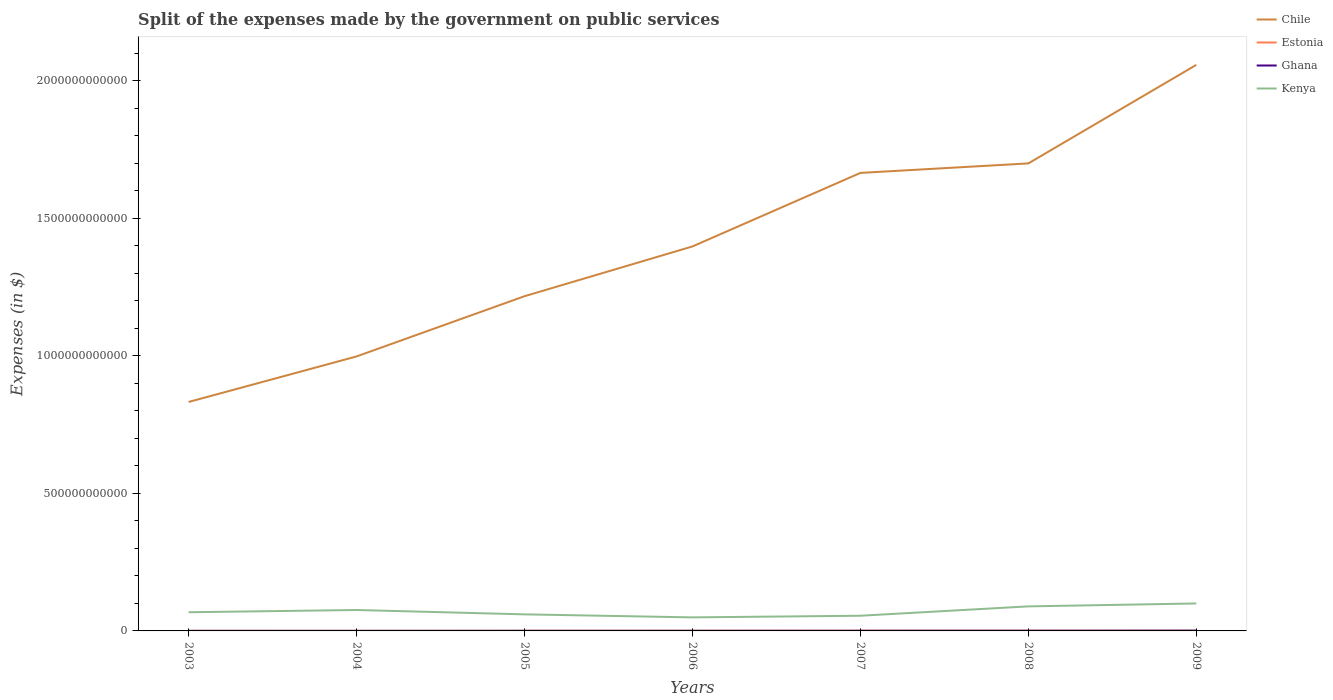Does the line corresponding to Ghana intersect with the line corresponding to Kenya?
Offer a terse response. No. Across all years, what is the maximum expenses made by the government on public services in Estonia?
Your answer should be compact. 4.04e+08. In which year was the expenses made by the government on public services in Ghana maximum?
Make the answer very short. 2003. What is the total expenses made by the government on public services in Kenya in the graph?
Make the answer very short. -5.98e+09. What is the difference between the highest and the second highest expenses made by the government on public services in Kenya?
Keep it short and to the point. 5.06e+1. How many lines are there?
Offer a very short reply. 4. What is the difference between two consecutive major ticks on the Y-axis?
Ensure brevity in your answer.  5.00e+11. Are the values on the major ticks of Y-axis written in scientific E-notation?
Make the answer very short. No. Does the graph contain any zero values?
Provide a short and direct response. No. How are the legend labels stacked?
Your answer should be very brief. Vertical. What is the title of the graph?
Keep it short and to the point. Split of the expenses made by the government on public services. Does "Lower middle income" appear as one of the legend labels in the graph?
Ensure brevity in your answer.  No. What is the label or title of the X-axis?
Your answer should be compact. Years. What is the label or title of the Y-axis?
Your response must be concise. Expenses (in $). What is the Expenses (in $) of Chile in 2003?
Keep it short and to the point. 8.32e+11. What is the Expenses (in $) of Estonia in 2003?
Ensure brevity in your answer.  4.29e+08. What is the Expenses (in $) of Ghana in 2003?
Provide a succinct answer. 2.06e+08. What is the Expenses (in $) in Kenya in 2003?
Keep it short and to the point. 6.79e+1. What is the Expenses (in $) of Chile in 2004?
Make the answer very short. 9.98e+11. What is the Expenses (in $) of Estonia in 2004?
Keep it short and to the point. 4.04e+08. What is the Expenses (in $) of Ghana in 2004?
Offer a very short reply. 2.46e+08. What is the Expenses (in $) in Kenya in 2004?
Your answer should be compact. 7.61e+1. What is the Expenses (in $) of Chile in 2005?
Ensure brevity in your answer.  1.22e+12. What is the Expenses (in $) of Estonia in 2005?
Your response must be concise. 4.46e+08. What is the Expenses (in $) in Ghana in 2005?
Ensure brevity in your answer.  4.02e+08. What is the Expenses (in $) in Kenya in 2005?
Provide a succinct answer. 6.02e+1. What is the Expenses (in $) of Chile in 2006?
Offer a very short reply. 1.40e+12. What is the Expenses (in $) of Estonia in 2006?
Offer a very short reply. 5.12e+08. What is the Expenses (in $) in Ghana in 2006?
Your answer should be compact. 4.57e+08. What is the Expenses (in $) of Kenya in 2006?
Offer a terse response. 4.92e+1. What is the Expenses (in $) in Chile in 2007?
Provide a succinct answer. 1.67e+12. What is the Expenses (in $) of Estonia in 2007?
Make the answer very short. 5.78e+08. What is the Expenses (in $) in Ghana in 2007?
Make the answer very short. 6.16e+08. What is the Expenses (in $) in Kenya in 2007?
Provide a succinct answer. 5.52e+1. What is the Expenses (in $) of Chile in 2008?
Your answer should be very brief. 1.70e+12. What is the Expenses (in $) in Estonia in 2008?
Keep it short and to the point. 6.60e+08. What is the Expenses (in $) of Ghana in 2008?
Offer a very short reply. 7.44e+08. What is the Expenses (in $) in Kenya in 2008?
Provide a short and direct response. 8.93e+1. What is the Expenses (in $) in Chile in 2009?
Provide a short and direct response. 2.06e+12. What is the Expenses (in $) in Estonia in 2009?
Your answer should be very brief. 6.36e+08. What is the Expenses (in $) in Ghana in 2009?
Your response must be concise. 1.09e+09. What is the Expenses (in $) in Kenya in 2009?
Offer a very short reply. 9.98e+1. Across all years, what is the maximum Expenses (in $) of Chile?
Keep it short and to the point. 2.06e+12. Across all years, what is the maximum Expenses (in $) of Estonia?
Your answer should be very brief. 6.60e+08. Across all years, what is the maximum Expenses (in $) of Ghana?
Ensure brevity in your answer.  1.09e+09. Across all years, what is the maximum Expenses (in $) in Kenya?
Your answer should be very brief. 9.98e+1. Across all years, what is the minimum Expenses (in $) in Chile?
Provide a succinct answer. 8.32e+11. Across all years, what is the minimum Expenses (in $) of Estonia?
Ensure brevity in your answer.  4.04e+08. Across all years, what is the minimum Expenses (in $) in Ghana?
Your response must be concise. 2.06e+08. Across all years, what is the minimum Expenses (in $) of Kenya?
Ensure brevity in your answer.  4.92e+1. What is the total Expenses (in $) of Chile in the graph?
Your answer should be very brief. 9.87e+12. What is the total Expenses (in $) in Estonia in the graph?
Your answer should be compact. 3.67e+09. What is the total Expenses (in $) of Ghana in the graph?
Offer a terse response. 3.76e+09. What is the total Expenses (in $) of Kenya in the graph?
Provide a short and direct response. 4.98e+11. What is the difference between the Expenses (in $) in Chile in 2003 and that in 2004?
Provide a succinct answer. -1.66e+11. What is the difference between the Expenses (in $) of Estonia in 2003 and that in 2004?
Offer a terse response. 2.44e+07. What is the difference between the Expenses (in $) of Ghana in 2003 and that in 2004?
Your answer should be very brief. -4.02e+07. What is the difference between the Expenses (in $) of Kenya in 2003 and that in 2004?
Make the answer very short. -8.12e+09. What is the difference between the Expenses (in $) of Chile in 2003 and that in 2005?
Your answer should be very brief. -3.85e+11. What is the difference between the Expenses (in $) of Estonia in 2003 and that in 2005?
Your answer should be compact. -1.75e+07. What is the difference between the Expenses (in $) of Ghana in 2003 and that in 2005?
Offer a very short reply. -1.96e+08. What is the difference between the Expenses (in $) in Kenya in 2003 and that in 2005?
Keep it short and to the point. 7.74e+09. What is the difference between the Expenses (in $) in Chile in 2003 and that in 2006?
Ensure brevity in your answer.  -5.66e+11. What is the difference between the Expenses (in $) of Estonia in 2003 and that in 2006?
Provide a short and direct response. -8.26e+07. What is the difference between the Expenses (in $) in Ghana in 2003 and that in 2006?
Offer a terse response. -2.51e+08. What is the difference between the Expenses (in $) in Kenya in 2003 and that in 2006?
Provide a succinct answer. 1.87e+1. What is the difference between the Expenses (in $) of Chile in 2003 and that in 2007?
Keep it short and to the point. -8.33e+11. What is the difference between the Expenses (in $) in Estonia in 2003 and that in 2007?
Your answer should be compact. -1.49e+08. What is the difference between the Expenses (in $) in Ghana in 2003 and that in 2007?
Your response must be concise. -4.10e+08. What is the difference between the Expenses (in $) in Kenya in 2003 and that in 2007?
Provide a succinct answer. 1.27e+1. What is the difference between the Expenses (in $) in Chile in 2003 and that in 2008?
Ensure brevity in your answer.  -8.67e+11. What is the difference between the Expenses (in $) of Estonia in 2003 and that in 2008?
Your response must be concise. -2.31e+08. What is the difference between the Expenses (in $) in Ghana in 2003 and that in 2008?
Provide a succinct answer. -5.38e+08. What is the difference between the Expenses (in $) of Kenya in 2003 and that in 2008?
Ensure brevity in your answer.  -2.13e+1. What is the difference between the Expenses (in $) of Chile in 2003 and that in 2009?
Keep it short and to the point. -1.23e+12. What is the difference between the Expenses (in $) of Estonia in 2003 and that in 2009?
Provide a short and direct response. -2.08e+08. What is the difference between the Expenses (in $) in Ghana in 2003 and that in 2009?
Provide a short and direct response. -8.81e+08. What is the difference between the Expenses (in $) of Kenya in 2003 and that in 2009?
Your answer should be very brief. -3.19e+1. What is the difference between the Expenses (in $) in Chile in 2004 and that in 2005?
Provide a short and direct response. -2.19e+11. What is the difference between the Expenses (in $) in Estonia in 2004 and that in 2005?
Give a very brief answer. -4.19e+07. What is the difference between the Expenses (in $) of Ghana in 2004 and that in 2005?
Your response must be concise. -1.56e+08. What is the difference between the Expenses (in $) in Kenya in 2004 and that in 2005?
Provide a succinct answer. 1.59e+1. What is the difference between the Expenses (in $) in Chile in 2004 and that in 2006?
Your answer should be compact. -4.00e+11. What is the difference between the Expenses (in $) of Estonia in 2004 and that in 2006?
Provide a short and direct response. -1.07e+08. What is the difference between the Expenses (in $) of Ghana in 2004 and that in 2006?
Keep it short and to the point. -2.11e+08. What is the difference between the Expenses (in $) in Kenya in 2004 and that in 2006?
Make the answer very short. 2.68e+1. What is the difference between the Expenses (in $) of Chile in 2004 and that in 2007?
Make the answer very short. -6.67e+11. What is the difference between the Expenses (in $) of Estonia in 2004 and that in 2007?
Give a very brief answer. -1.74e+08. What is the difference between the Expenses (in $) of Ghana in 2004 and that in 2007?
Provide a short and direct response. -3.70e+08. What is the difference between the Expenses (in $) in Kenya in 2004 and that in 2007?
Your response must be concise. 2.08e+1. What is the difference between the Expenses (in $) in Chile in 2004 and that in 2008?
Offer a terse response. -7.02e+11. What is the difference between the Expenses (in $) of Estonia in 2004 and that in 2008?
Keep it short and to the point. -2.56e+08. What is the difference between the Expenses (in $) in Ghana in 2004 and that in 2008?
Give a very brief answer. -4.98e+08. What is the difference between the Expenses (in $) in Kenya in 2004 and that in 2008?
Make the answer very short. -1.32e+1. What is the difference between the Expenses (in $) in Chile in 2004 and that in 2009?
Offer a terse response. -1.06e+12. What is the difference between the Expenses (in $) of Estonia in 2004 and that in 2009?
Ensure brevity in your answer.  -2.32e+08. What is the difference between the Expenses (in $) of Ghana in 2004 and that in 2009?
Your answer should be very brief. -8.41e+08. What is the difference between the Expenses (in $) in Kenya in 2004 and that in 2009?
Your answer should be very brief. -2.38e+1. What is the difference between the Expenses (in $) of Chile in 2005 and that in 2006?
Your answer should be compact. -1.81e+11. What is the difference between the Expenses (in $) of Estonia in 2005 and that in 2006?
Give a very brief answer. -6.51e+07. What is the difference between the Expenses (in $) of Ghana in 2005 and that in 2006?
Your answer should be very brief. -5.49e+07. What is the difference between the Expenses (in $) of Kenya in 2005 and that in 2006?
Ensure brevity in your answer.  1.10e+1. What is the difference between the Expenses (in $) in Chile in 2005 and that in 2007?
Provide a short and direct response. -4.48e+11. What is the difference between the Expenses (in $) of Estonia in 2005 and that in 2007?
Ensure brevity in your answer.  -1.32e+08. What is the difference between the Expenses (in $) of Ghana in 2005 and that in 2007?
Ensure brevity in your answer.  -2.14e+08. What is the difference between the Expenses (in $) of Kenya in 2005 and that in 2007?
Provide a short and direct response. 4.99e+09. What is the difference between the Expenses (in $) of Chile in 2005 and that in 2008?
Provide a short and direct response. -4.83e+11. What is the difference between the Expenses (in $) in Estonia in 2005 and that in 2008?
Offer a very short reply. -2.14e+08. What is the difference between the Expenses (in $) in Ghana in 2005 and that in 2008?
Provide a succinct answer. -3.42e+08. What is the difference between the Expenses (in $) of Kenya in 2005 and that in 2008?
Keep it short and to the point. -2.91e+1. What is the difference between the Expenses (in $) in Chile in 2005 and that in 2009?
Your response must be concise. -8.41e+11. What is the difference between the Expenses (in $) of Estonia in 2005 and that in 2009?
Provide a succinct answer. -1.90e+08. What is the difference between the Expenses (in $) in Ghana in 2005 and that in 2009?
Offer a terse response. -6.85e+08. What is the difference between the Expenses (in $) of Kenya in 2005 and that in 2009?
Your answer should be compact. -3.96e+1. What is the difference between the Expenses (in $) of Chile in 2006 and that in 2007?
Your answer should be compact. -2.67e+11. What is the difference between the Expenses (in $) in Estonia in 2006 and that in 2007?
Make the answer very short. -6.65e+07. What is the difference between the Expenses (in $) in Ghana in 2006 and that in 2007?
Offer a terse response. -1.59e+08. What is the difference between the Expenses (in $) of Kenya in 2006 and that in 2007?
Provide a short and direct response. -5.98e+09. What is the difference between the Expenses (in $) of Chile in 2006 and that in 2008?
Your response must be concise. -3.02e+11. What is the difference between the Expenses (in $) of Estonia in 2006 and that in 2008?
Provide a succinct answer. -1.49e+08. What is the difference between the Expenses (in $) of Ghana in 2006 and that in 2008?
Ensure brevity in your answer.  -2.87e+08. What is the difference between the Expenses (in $) in Kenya in 2006 and that in 2008?
Provide a short and direct response. -4.00e+1. What is the difference between the Expenses (in $) in Chile in 2006 and that in 2009?
Make the answer very short. -6.60e+11. What is the difference between the Expenses (in $) of Estonia in 2006 and that in 2009?
Give a very brief answer. -1.25e+08. What is the difference between the Expenses (in $) in Ghana in 2006 and that in 2009?
Your answer should be compact. -6.30e+08. What is the difference between the Expenses (in $) in Kenya in 2006 and that in 2009?
Offer a terse response. -5.06e+1. What is the difference between the Expenses (in $) in Chile in 2007 and that in 2008?
Your response must be concise. -3.46e+1. What is the difference between the Expenses (in $) of Estonia in 2007 and that in 2008?
Provide a short and direct response. -8.21e+07. What is the difference between the Expenses (in $) of Ghana in 2007 and that in 2008?
Provide a short and direct response. -1.28e+08. What is the difference between the Expenses (in $) of Kenya in 2007 and that in 2008?
Make the answer very short. -3.41e+1. What is the difference between the Expenses (in $) of Chile in 2007 and that in 2009?
Keep it short and to the point. -3.93e+11. What is the difference between the Expenses (in $) in Estonia in 2007 and that in 2009?
Your answer should be compact. -5.85e+07. What is the difference between the Expenses (in $) of Ghana in 2007 and that in 2009?
Offer a terse response. -4.72e+08. What is the difference between the Expenses (in $) in Kenya in 2007 and that in 2009?
Your answer should be compact. -4.46e+1. What is the difference between the Expenses (in $) in Chile in 2008 and that in 2009?
Offer a very short reply. -3.58e+11. What is the difference between the Expenses (in $) in Estonia in 2008 and that in 2009?
Keep it short and to the point. 2.36e+07. What is the difference between the Expenses (in $) in Ghana in 2008 and that in 2009?
Provide a short and direct response. -3.44e+08. What is the difference between the Expenses (in $) of Kenya in 2008 and that in 2009?
Keep it short and to the point. -1.06e+1. What is the difference between the Expenses (in $) of Chile in 2003 and the Expenses (in $) of Estonia in 2004?
Provide a short and direct response. 8.32e+11. What is the difference between the Expenses (in $) in Chile in 2003 and the Expenses (in $) in Ghana in 2004?
Your answer should be compact. 8.32e+11. What is the difference between the Expenses (in $) of Chile in 2003 and the Expenses (in $) of Kenya in 2004?
Give a very brief answer. 7.56e+11. What is the difference between the Expenses (in $) in Estonia in 2003 and the Expenses (in $) in Ghana in 2004?
Keep it short and to the point. 1.83e+08. What is the difference between the Expenses (in $) in Estonia in 2003 and the Expenses (in $) in Kenya in 2004?
Offer a very short reply. -7.56e+1. What is the difference between the Expenses (in $) of Ghana in 2003 and the Expenses (in $) of Kenya in 2004?
Provide a succinct answer. -7.58e+1. What is the difference between the Expenses (in $) in Chile in 2003 and the Expenses (in $) in Estonia in 2005?
Your response must be concise. 8.32e+11. What is the difference between the Expenses (in $) of Chile in 2003 and the Expenses (in $) of Ghana in 2005?
Provide a succinct answer. 8.32e+11. What is the difference between the Expenses (in $) in Chile in 2003 and the Expenses (in $) in Kenya in 2005?
Your answer should be compact. 7.72e+11. What is the difference between the Expenses (in $) of Estonia in 2003 and the Expenses (in $) of Ghana in 2005?
Your answer should be very brief. 2.66e+07. What is the difference between the Expenses (in $) of Estonia in 2003 and the Expenses (in $) of Kenya in 2005?
Offer a terse response. -5.98e+1. What is the difference between the Expenses (in $) in Ghana in 2003 and the Expenses (in $) in Kenya in 2005?
Give a very brief answer. -6.00e+1. What is the difference between the Expenses (in $) of Chile in 2003 and the Expenses (in $) of Estonia in 2006?
Your response must be concise. 8.32e+11. What is the difference between the Expenses (in $) of Chile in 2003 and the Expenses (in $) of Ghana in 2006?
Your answer should be very brief. 8.32e+11. What is the difference between the Expenses (in $) of Chile in 2003 and the Expenses (in $) of Kenya in 2006?
Ensure brevity in your answer.  7.83e+11. What is the difference between the Expenses (in $) in Estonia in 2003 and the Expenses (in $) in Ghana in 2006?
Your answer should be very brief. -2.83e+07. What is the difference between the Expenses (in $) of Estonia in 2003 and the Expenses (in $) of Kenya in 2006?
Your answer should be very brief. -4.88e+1. What is the difference between the Expenses (in $) of Ghana in 2003 and the Expenses (in $) of Kenya in 2006?
Offer a terse response. -4.90e+1. What is the difference between the Expenses (in $) of Chile in 2003 and the Expenses (in $) of Estonia in 2007?
Provide a short and direct response. 8.32e+11. What is the difference between the Expenses (in $) in Chile in 2003 and the Expenses (in $) in Ghana in 2007?
Give a very brief answer. 8.32e+11. What is the difference between the Expenses (in $) of Chile in 2003 and the Expenses (in $) of Kenya in 2007?
Make the answer very short. 7.77e+11. What is the difference between the Expenses (in $) in Estonia in 2003 and the Expenses (in $) in Ghana in 2007?
Your answer should be very brief. -1.87e+08. What is the difference between the Expenses (in $) in Estonia in 2003 and the Expenses (in $) in Kenya in 2007?
Keep it short and to the point. -5.48e+1. What is the difference between the Expenses (in $) in Ghana in 2003 and the Expenses (in $) in Kenya in 2007?
Keep it short and to the point. -5.50e+1. What is the difference between the Expenses (in $) in Chile in 2003 and the Expenses (in $) in Estonia in 2008?
Give a very brief answer. 8.32e+11. What is the difference between the Expenses (in $) of Chile in 2003 and the Expenses (in $) of Ghana in 2008?
Your answer should be very brief. 8.32e+11. What is the difference between the Expenses (in $) in Chile in 2003 and the Expenses (in $) in Kenya in 2008?
Provide a succinct answer. 7.43e+11. What is the difference between the Expenses (in $) of Estonia in 2003 and the Expenses (in $) of Ghana in 2008?
Offer a very short reply. -3.15e+08. What is the difference between the Expenses (in $) in Estonia in 2003 and the Expenses (in $) in Kenya in 2008?
Make the answer very short. -8.88e+1. What is the difference between the Expenses (in $) in Ghana in 2003 and the Expenses (in $) in Kenya in 2008?
Your answer should be compact. -8.91e+1. What is the difference between the Expenses (in $) in Chile in 2003 and the Expenses (in $) in Estonia in 2009?
Your answer should be very brief. 8.32e+11. What is the difference between the Expenses (in $) in Chile in 2003 and the Expenses (in $) in Ghana in 2009?
Provide a short and direct response. 8.31e+11. What is the difference between the Expenses (in $) in Chile in 2003 and the Expenses (in $) in Kenya in 2009?
Provide a short and direct response. 7.33e+11. What is the difference between the Expenses (in $) of Estonia in 2003 and the Expenses (in $) of Ghana in 2009?
Offer a terse response. -6.59e+08. What is the difference between the Expenses (in $) of Estonia in 2003 and the Expenses (in $) of Kenya in 2009?
Your answer should be compact. -9.94e+1. What is the difference between the Expenses (in $) in Ghana in 2003 and the Expenses (in $) in Kenya in 2009?
Your answer should be compact. -9.96e+1. What is the difference between the Expenses (in $) in Chile in 2004 and the Expenses (in $) in Estonia in 2005?
Provide a succinct answer. 9.98e+11. What is the difference between the Expenses (in $) of Chile in 2004 and the Expenses (in $) of Ghana in 2005?
Keep it short and to the point. 9.98e+11. What is the difference between the Expenses (in $) of Chile in 2004 and the Expenses (in $) of Kenya in 2005?
Ensure brevity in your answer.  9.38e+11. What is the difference between the Expenses (in $) of Estonia in 2004 and the Expenses (in $) of Ghana in 2005?
Your answer should be very brief. 2.19e+06. What is the difference between the Expenses (in $) in Estonia in 2004 and the Expenses (in $) in Kenya in 2005?
Make the answer very short. -5.98e+1. What is the difference between the Expenses (in $) of Ghana in 2004 and the Expenses (in $) of Kenya in 2005?
Keep it short and to the point. -6.00e+1. What is the difference between the Expenses (in $) in Chile in 2004 and the Expenses (in $) in Estonia in 2006?
Make the answer very short. 9.98e+11. What is the difference between the Expenses (in $) of Chile in 2004 and the Expenses (in $) of Ghana in 2006?
Give a very brief answer. 9.98e+11. What is the difference between the Expenses (in $) of Chile in 2004 and the Expenses (in $) of Kenya in 2006?
Your response must be concise. 9.49e+11. What is the difference between the Expenses (in $) in Estonia in 2004 and the Expenses (in $) in Ghana in 2006?
Provide a short and direct response. -5.27e+07. What is the difference between the Expenses (in $) in Estonia in 2004 and the Expenses (in $) in Kenya in 2006?
Your response must be concise. -4.88e+1. What is the difference between the Expenses (in $) in Ghana in 2004 and the Expenses (in $) in Kenya in 2006?
Your answer should be very brief. -4.90e+1. What is the difference between the Expenses (in $) in Chile in 2004 and the Expenses (in $) in Estonia in 2007?
Provide a succinct answer. 9.97e+11. What is the difference between the Expenses (in $) of Chile in 2004 and the Expenses (in $) of Ghana in 2007?
Your answer should be compact. 9.97e+11. What is the difference between the Expenses (in $) in Chile in 2004 and the Expenses (in $) in Kenya in 2007?
Ensure brevity in your answer.  9.43e+11. What is the difference between the Expenses (in $) in Estonia in 2004 and the Expenses (in $) in Ghana in 2007?
Give a very brief answer. -2.11e+08. What is the difference between the Expenses (in $) of Estonia in 2004 and the Expenses (in $) of Kenya in 2007?
Your response must be concise. -5.48e+1. What is the difference between the Expenses (in $) in Ghana in 2004 and the Expenses (in $) in Kenya in 2007?
Ensure brevity in your answer.  -5.50e+1. What is the difference between the Expenses (in $) in Chile in 2004 and the Expenses (in $) in Estonia in 2008?
Your answer should be compact. 9.97e+11. What is the difference between the Expenses (in $) in Chile in 2004 and the Expenses (in $) in Ghana in 2008?
Keep it short and to the point. 9.97e+11. What is the difference between the Expenses (in $) of Chile in 2004 and the Expenses (in $) of Kenya in 2008?
Ensure brevity in your answer.  9.09e+11. What is the difference between the Expenses (in $) in Estonia in 2004 and the Expenses (in $) in Ghana in 2008?
Make the answer very short. -3.39e+08. What is the difference between the Expenses (in $) of Estonia in 2004 and the Expenses (in $) of Kenya in 2008?
Make the answer very short. -8.89e+1. What is the difference between the Expenses (in $) of Ghana in 2004 and the Expenses (in $) of Kenya in 2008?
Keep it short and to the point. -8.90e+1. What is the difference between the Expenses (in $) of Chile in 2004 and the Expenses (in $) of Estonia in 2009?
Offer a terse response. 9.97e+11. What is the difference between the Expenses (in $) of Chile in 2004 and the Expenses (in $) of Ghana in 2009?
Provide a short and direct response. 9.97e+11. What is the difference between the Expenses (in $) of Chile in 2004 and the Expenses (in $) of Kenya in 2009?
Make the answer very short. 8.98e+11. What is the difference between the Expenses (in $) in Estonia in 2004 and the Expenses (in $) in Ghana in 2009?
Provide a short and direct response. -6.83e+08. What is the difference between the Expenses (in $) in Estonia in 2004 and the Expenses (in $) in Kenya in 2009?
Give a very brief answer. -9.94e+1. What is the difference between the Expenses (in $) of Ghana in 2004 and the Expenses (in $) of Kenya in 2009?
Give a very brief answer. -9.96e+1. What is the difference between the Expenses (in $) in Chile in 2005 and the Expenses (in $) in Estonia in 2006?
Your answer should be compact. 1.22e+12. What is the difference between the Expenses (in $) of Chile in 2005 and the Expenses (in $) of Ghana in 2006?
Your response must be concise. 1.22e+12. What is the difference between the Expenses (in $) of Chile in 2005 and the Expenses (in $) of Kenya in 2006?
Ensure brevity in your answer.  1.17e+12. What is the difference between the Expenses (in $) in Estonia in 2005 and the Expenses (in $) in Ghana in 2006?
Provide a short and direct response. -1.08e+07. What is the difference between the Expenses (in $) in Estonia in 2005 and the Expenses (in $) in Kenya in 2006?
Make the answer very short. -4.88e+1. What is the difference between the Expenses (in $) of Ghana in 2005 and the Expenses (in $) of Kenya in 2006?
Offer a very short reply. -4.88e+1. What is the difference between the Expenses (in $) in Chile in 2005 and the Expenses (in $) in Estonia in 2007?
Your answer should be very brief. 1.22e+12. What is the difference between the Expenses (in $) in Chile in 2005 and the Expenses (in $) in Ghana in 2007?
Make the answer very short. 1.22e+12. What is the difference between the Expenses (in $) of Chile in 2005 and the Expenses (in $) of Kenya in 2007?
Ensure brevity in your answer.  1.16e+12. What is the difference between the Expenses (in $) of Estonia in 2005 and the Expenses (in $) of Ghana in 2007?
Your answer should be compact. -1.69e+08. What is the difference between the Expenses (in $) of Estonia in 2005 and the Expenses (in $) of Kenya in 2007?
Provide a short and direct response. -5.48e+1. What is the difference between the Expenses (in $) of Ghana in 2005 and the Expenses (in $) of Kenya in 2007?
Your answer should be very brief. -5.48e+1. What is the difference between the Expenses (in $) in Chile in 2005 and the Expenses (in $) in Estonia in 2008?
Your answer should be very brief. 1.22e+12. What is the difference between the Expenses (in $) in Chile in 2005 and the Expenses (in $) in Ghana in 2008?
Provide a succinct answer. 1.22e+12. What is the difference between the Expenses (in $) of Chile in 2005 and the Expenses (in $) of Kenya in 2008?
Provide a succinct answer. 1.13e+12. What is the difference between the Expenses (in $) in Estonia in 2005 and the Expenses (in $) in Ghana in 2008?
Your answer should be compact. -2.97e+08. What is the difference between the Expenses (in $) in Estonia in 2005 and the Expenses (in $) in Kenya in 2008?
Provide a succinct answer. -8.88e+1. What is the difference between the Expenses (in $) in Ghana in 2005 and the Expenses (in $) in Kenya in 2008?
Your response must be concise. -8.89e+1. What is the difference between the Expenses (in $) of Chile in 2005 and the Expenses (in $) of Estonia in 2009?
Ensure brevity in your answer.  1.22e+12. What is the difference between the Expenses (in $) in Chile in 2005 and the Expenses (in $) in Ghana in 2009?
Your answer should be very brief. 1.22e+12. What is the difference between the Expenses (in $) of Chile in 2005 and the Expenses (in $) of Kenya in 2009?
Offer a very short reply. 1.12e+12. What is the difference between the Expenses (in $) in Estonia in 2005 and the Expenses (in $) in Ghana in 2009?
Provide a short and direct response. -6.41e+08. What is the difference between the Expenses (in $) in Estonia in 2005 and the Expenses (in $) in Kenya in 2009?
Provide a short and direct response. -9.94e+1. What is the difference between the Expenses (in $) of Ghana in 2005 and the Expenses (in $) of Kenya in 2009?
Provide a short and direct response. -9.94e+1. What is the difference between the Expenses (in $) in Chile in 2006 and the Expenses (in $) in Estonia in 2007?
Keep it short and to the point. 1.40e+12. What is the difference between the Expenses (in $) of Chile in 2006 and the Expenses (in $) of Ghana in 2007?
Your response must be concise. 1.40e+12. What is the difference between the Expenses (in $) of Chile in 2006 and the Expenses (in $) of Kenya in 2007?
Offer a very short reply. 1.34e+12. What is the difference between the Expenses (in $) of Estonia in 2006 and the Expenses (in $) of Ghana in 2007?
Ensure brevity in your answer.  -1.04e+08. What is the difference between the Expenses (in $) of Estonia in 2006 and the Expenses (in $) of Kenya in 2007?
Make the answer very short. -5.47e+1. What is the difference between the Expenses (in $) of Ghana in 2006 and the Expenses (in $) of Kenya in 2007?
Offer a very short reply. -5.48e+1. What is the difference between the Expenses (in $) in Chile in 2006 and the Expenses (in $) in Estonia in 2008?
Offer a very short reply. 1.40e+12. What is the difference between the Expenses (in $) in Chile in 2006 and the Expenses (in $) in Ghana in 2008?
Provide a short and direct response. 1.40e+12. What is the difference between the Expenses (in $) of Chile in 2006 and the Expenses (in $) of Kenya in 2008?
Offer a terse response. 1.31e+12. What is the difference between the Expenses (in $) of Estonia in 2006 and the Expenses (in $) of Ghana in 2008?
Make the answer very short. -2.32e+08. What is the difference between the Expenses (in $) in Estonia in 2006 and the Expenses (in $) in Kenya in 2008?
Ensure brevity in your answer.  -8.88e+1. What is the difference between the Expenses (in $) of Ghana in 2006 and the Expenses (in $) of Kenya in 2008?
Your response must be concise. -8.88e+1. What is the difference between the Expenses (in $) in Chile in 2006 and the Expenses (in $) in Estonia in 2009?
Give a very brief answer. 1.40e+12. What is the difference between the Expenses (in $) of Chile in 2006 and the Expenses (in $) of Ghana in 2009?
Make the answer very short. 1.40e+12. What is the difference between the Expenses (in $) of Chile in 2006 and the Expenses (in $) of Kenya in 2009?
Make the answer very short. 1.30e+12. What is the difference between the Expenses (in $) in Estonia in 2006 and the Expenses (in $) in Ghana in 2009?
Your response must be concise. -5.76e+08. What is the difference between the Expenses (in $) of Estonia in 2006 and the Expenses (in $) of Kenya in 2009?
Provide a succinct answer. -9.93e+1. What is the difference between the Expenses (in $) in Ghana in 2006 and the Expenses (in $) in Kenya in 2009?
Provide a short and direct response. -9.94e+1. What is the difference between the Expenses (in $) in Chile in 2007 and the Expenses (in $) in Estonia in 2008?
Make the answer very short. 1.66e+12. What is the difference between the Expenses (in $) in Chile in 2007 and the Expenses (in $) in Ghana in 2008?
Your response must be concise. 1.66e+12. What is the difference between the Expenses (in $) in Chile in 2007 and the Expenses (in $) in Kenya in 2008?
Offer a terse response. 1.58e+12. What is the difference between the Expenses (in $) in Estonia in 2007 and the Expenses (in $) in Ghana in 2008?
Offer a terse response. -1.66e+08. What is the difference between the Expenses (in $) in Estonia in 2007 and the Expenses (in $) in Kenya in 2008?
Offer a terse response. -8.87e+1. What is the difference between the Expenses (in $) in Ghana in 2007 and the Expenses (in $) in Kenya in 2008?
Give a very brief answer. -8.87e+1. What is the difference between the Expenses (in $) in Chile in 2007 and the Expenses (in $) in Estonia in 2009?
Provide a succinct answer. 1.66e+12. What is the difference between the Expenses (in $) of Chile in 2007 and the Expenses (in $) of Ghana in 2009?
Provide a short and direct response. 1.66e+12. What is the difference between the Expenses (in $) of Chile in 2007 and the Expenses (in $) of Kenya in 2009?
Your answer should be very brief. 1.57e+12. What is the difference between the Expenses (in $) of Estonia in 2007 and the Expenses (in $) of Ghana in 2009?
Provide a succinct answer. -5.09e+08. What is the difference between the Expenses (in $) in Estonia in 2007 and the Expenses (in $) in Kenya in 2009?
Ensure brevity in your answer.  -9.93e+1. What is the difference between the Expenses (in $) in Ghana in 2007 and the Expenses (in $) in Kenya in 2009?
Your answer should be very brief. -9.92e+1. What is the difference between the Expenses (in $) in Chile in 2008 and the Expenses (in $) in Estonia in 2009?
Provide a succinct answer. 1.70e+12. What is the difference between the Expenses (in $) of Chile in 2008 and the Expenses (in $) of Ghana in 2009?
Provide a succinct answer. 1.70e+12. What is the difference between the Expenses (in $) of Chile in 2008 and the Expenses (in $) of Kenya in 2009?
Keep it short and to the point. 1.60e+12. What is the difference between the Expenses (in $) in Estonia in 2008 and the Expenses (in $) in Ghana in 2009?
Your answer should be very brief. -4.27e+08. What is the difference between the Expenses (in $) in Estonia in 2008 and the Expenses (in $) in Kenya in 2009?
Your response must be concise. -9.92e+1. What is the difference between the Expenses (in $) of Ghana in 2008 and the Expenses (in $) of Kenya in 2009?
Make the answer very short. -9.91e+1. What is the average Expenses (in $) in Chile per year?
Provide a succinct answer. 1.41e+12. What is the average Expenses (in $) in Estonia per year?
Your answer should be compact. 5.24e+08. What is the average Expenses (in $) in Ghana per year?
Offer a very short reply. 5.37e+08. What is the average Expenses (in $) in Kenya per year?
Provide a succinct answer. 7.11e+1. In the year 2003, what is the difference between the Expenses (in $) of Chile and Expenses (in $) of Estonia?
Make the answer very short. 8.32e+11. In the year 2003, what is the difference between the Expenses (in $) in Chile and Expenses (in $) in Ghana?
Provide a short and direct response. 8.32e+11. In the year 2003, what is the difference between the Expenses (in $) in Chile and Expenses (in $) in Kenya?
Keep it short and to the point. 7.65e+11. In the year 2003, what is the difference between the Expenses (in $) of Estonia and Expenses (in $) of Ghana?
Offer a terse response. 2.23e+08. In the year 2003, what is the difference between the Expenses (in $) of Estonia and Expenses (in $) of Kenya?
Make the answer very short. -6.75e+1. In the year 2003, what is the difference between the Expenses (in $) of Ghana and Expenses (in $) of Kenya?
Ensure brevity in your answer.  -6.77e+1. In the year 2004, what is the difference between the Expenses (in $) in Chile and Expenses (in $) in Estonia?
Offer a terse response. 9.98e+11. In the year 2004, what is the difference between the Expenses (in $) in Chile and Expenses (in $) in Ghana?
Keep it short and to the point. 9.98e+11. In the year 2004, what is the difference between the Expenses (in $) in Chile and Expenses (in $) in Kenya?
Keep it short and to the point. 9.22e+11. In the year 2004, what is the difference between the Expenses (in $) of Estonia and Expenses (in $) of Ghana?
Ensure brevity in your answer.  1.58e+08. In the year 2004, what is the difference between the Expenses (in $) of Estonia and Expenses (in $) of Kenya?
Provide a short and direct response. -7.57e+1. In the year 2004, what is the difference between the Expenses (in $) of Ghana and Expenses (in $) of Kenya?
Ensure brevity in your answer.  -7.58e+1. In the year 2005, what is the difference between the Expenses (in $) of Chile and Expenses (in $) of Estonia?
Make the answer very short. 1.22e+12. In the year 2005, what is the difference between the Expenses (in $) in Chile and Expenses (in $) in Ghana?
Provide a succinct answer. 1.22e+12. In the year 2005, what is the difference between the Expenses (in $) in Chile and Expenses (in $) in Kenya?
Ensure brevity in your answer.  1.16e+12. In the year 2005, what is the difference between the Expenses (in $) in Estonia and Expenses (in $) in Ghana?
Your answer should be compact. 4.41e+07. In the year 2005, what is the difference between the Expenses (in $) of Estonia and Expenses (in $) of Kenya?
Keep it short and to the point. -5.98e+1. In the year 2005, what is the difference between the Expenses (in $) in Ghana and Expenses (in $) in Kenya?
Make the answer very short. -5.98e+1. In the year 2006, what is the difference between the Expenses (in $) in Chile and Expenses (in $) in Estonia?
Your response must be concise. 1.40e+12. In the year 2006, what is the difference between the Expenses (in $) in Chile and Expenses (in $) in Ghana?
Offer a very short reply. 1.40e+12. In the year 2006, what is the difference between the Expenses (in $) of Chile and Expenses (in $) of Kenya?
Your response must be concise. 1.35e+12. In the year 2006, what is the difference between the Expenses (in $) of Estonia and Expenses (in $) of Ghana?
Keep it short and to the point. 5.43e+07. In the year 2006, what is the difference between the Expenses (in $) of Estonia and Expenses (in $) of Kenya?
Offer a terse response. -4.87e+1. In the year 2006, what is the difference between the Expenses (in $) of Ghana and Expenses (in $) of Kenya?
Provide a short and direct response. -4.88e+1. In the year 2007, what is the difference between the Expenses (in $) in Chile and Expenses (in $) in Estonia?
Ensure brevity in your answer.  1.66e+12. In the year 2007, what is the difference between the Expenses (in $) in Chile and Expenses (in $) in Ghana?
Ensure brevity in your answer.  1.66e+12. In the year 2007, what is the difference between the Expenses (in $) in Chile and Expenses (in $) in Kenya?
Your answer should be very brief. 1.61e+12. In the year 2007, what is the difference between the Expenses (in $) of Estonia and Expenses (in $) of Ghana?
Provide a succinct answer. -3.78e+07. In the year 2007, what is the difference between the Expenses (in $) in Estonia and Expenses (in $) in Kenya?
Provide a short and direct response. -5.46e+1. In the year 2007, what is the difference between the Expenses (in $) of Ghana and Expenses (in $) of Kenya?
Keep it short and to the point. -5.46e+1. In the year 2008, what is the difference between the Expenses (in $) in Chile and Expenses (in $) in Estonia?
Provide a succinct answer. 1.70e+12. In the year 2008, what is the difference between the Expenses (in $) of Chile and Expenses (in $) of Ghana?
Offer a very short reply. 1.70e+12. In the year 2008, what is the difference between the Expenses (in $) in Chile and Expenses (in $) in Kenya?
Provide a short and direct response. 1.61e+12. In the year 2008, what is the difference between the Expenses (in $) in Estonia and Expenses (in $) in Ghana?
Your response must be concise. -8.37e+07. In the year 2008, what is the difference between the Expenses (in $) of Estonia and Expenses (in $) of Kenya?
Offer a very short reply. -8.86e+1. In the year 2008, what is the difference between the Expenses (in $) in Ghana and Expenses (in $) in Kenya?
Provide a short and direct response. -8.85e+1. In the year 2009, what is the difference between the Expenses (in $) in Chile and Expenses (in $) in Estonia?
Provide a succinct answer. 2.06e+12. In the year 2009, what is the difference between the Expenses (in $) of Chile and Expenses (in $) of Ghana?
Your answer should be very brief. 2.06e+12. In the year 2009, what is the difference between the Expenses (in $) in Chile and Expenses (in $) in Kenya?
Keep it short and to the point. 1.96e+12. In the year 2009, what is the difference between the Expenses (in $) in Estonia and Expenses (in $) in Ghana?
Your response must be concise. -4.51e+08. In the year 2009, what is the difference between the Expenses (in $) in Estonia and Expenses (in $) in Kenya?
Keep it short and to the point. -9.92e+1. In the year 2009, what is the difference between the Expenses (in $) of Ghana and Expenses (in $) of Kenya?
Offer a very short reply. -9.87e+1. What is the ratio of the Expenses (in $) in Chile in 2003 to that in 2004?
Provide a succinct answer. 0.83. What is the ratio of the Expenses (in $) of Estonia in 2003 to that in 2004?
Keep it short and to the point. 1.06. What is the ratio of the Expenses (in $) in Ghana in 2003 to that in 2004?
Keep it short and to the point. 0.84. What is the ratio of the Expenses (in $) of Kenya in 2003 to that in 2004?
Offer a very short reply. 0.89. What is the ratio of the Expenses (in $) in Chile in 2003 to that in 2005?
Offer a terse response. 0.68. What is the ratio of the Expenses (in $) of Estonia in 2003 to that in 2005?
Keep it short and to the point. 0.96. What is the ratio of the Expenses (in $) in Ghana in 2003 to that in 2005?
Your response must be concise. 0.51. What is the ratio of the Expenses (in $) of Kenya in 2003 to that in 2005?
Your answer should be compact. 1.13. What is the ratio of the Expenses (in $) in Chile in 2003 to that in 2006?
Provide a short and direct response. 0.6. What is the ratio of the Expenses (in $) in Estonia in 2003 to that in 2006?
Give a very brief answer. 0.84. What is the ratio of the Expenses (in $) of Ghana in 2003 to that in 2006?
Give a very brief answer. 0.45. What is the ratio of the Expenses (in $) in Kenya in 2003 to that in 2006?
Your response must be concise. 1.38. What is the ratio of the Expenses (in $) of Chile in 2003 to that in 2007?
Offer a very short reply. 0.5. What is the ratio of the Expenses (in $) in Estonia in 2003 to that in 2007?
Offer a very short reply. 0.74. What is the ratio of the Expenses (in $) of Ghana in 2003 to that in 2007?
Make the answer very short. 0.33. What is the ratio of the Expenses (in $) of Kenya in 2003 to that in 2007?
Ensure brevity in your answer.  1.23. What is the ratio of the Expenses (in $) in Chile in 2003 to that in 2008?
Provide a succinct answer. 0.49. What is the ratio of the Expenses (in $) of Estonia in 2003 to that in 2008?
Give a very brief answer. 0.65. What is the ratio of the Expenses (in $) of Ghana in 2003 to that in 2008?
Keep it short and to the point. 0.28. What is the ratio of the Expenses (in $) in Kenya in 2003 to that in 2008?
Give a very brief answer. 0.76. What is the ratio of the Expenses (in $) in Chile in 2003 to that in 2009?
Provide a succinct answer. 0.4. What is the ratio of the Expenses (in $) in Estonia in 2003 to that in 2009?
Give a very brief answer. 0.67. What is the ratio of the Expenses (in $) of Ghana in 2003 to that in 2009?
Make the answer very short. 0.19. What is the ratio of the Expenses (in $) of Kenya in 2003 to that in 2009?
Give a very brief answer. 0.68. What is the ratio of the Expenses (in $) of Chile in 2004 to that in 2005?
Your answer should be compact. 0.82. What is the ratio of the Expenses (in $) of Estonia in 2004 to that in 2005?
Keep it short and to the point. 0.91. What is the ratio of the Expenses (in $) of Ghana in 2004 to that in 2005?
Give a very brief answer. 0.61. What is the ratio of the Expenses (in $) in Kenya in 2004 to that in 2005?
Give a very brief answer. 1.26. What is the ratio of the Expenses (in $) of Chile in 2004 to that in 2006?
Make the answer very short. 0.71. What is the ratio of the Expenses (in $) of Estonia in 2004 to that in 2006?
Provide a short and direct response. 0.79. What is the ratio of the Expenses (in $) in Ghana in 2004 to that in 2006?
Offer a very short reply. 0.54. What is the ratio of the Expenses (in $) of Kenya in 2004 to that in 2006?
Your answer should be very brief. 1.54. What is the ratio of the Expenses (in $) in Chile in 2004 to that in 2007?
Your answer should be compact. 0.6. What is the ratio of the Expenses (in $) of Estonia in 2004 to that in 2007?
Offer a very short reply. 0.7. What is the ratio of the Expenses (in $) in Ghana in 2004 to that in 2007?
Provide a succinct answer. 0.4. What is the ratio of the Expenses (in $) of Kenya in 2004 to that in 2007?
Make the answer very short. 1.38. What is the ratio of the Expenses (in $) of Chile in 2004 to that in 2008?
Your response must be concise. 0.59. What is the ratio of the Expenses (in $) of Estonia in 2004 to that in 2008?
Give a very brief answer. 0.61. What is the ratio of the Expenses (in $) of Ghana in 2004 to that in 2008?
Provide a succinct answer. 0.33. What is the ratio of the Expenses (in $) of Kenya in 2004 to that in 2008?
Give a very brief answer. 0.85. What is the ratio of the Expenses (in $) of Chile in 2004 to that in 2009?
Provide a short and direct response. 0.48. What is the ratio of the Expenses (in $) in Estonia in 2004 to that in 2009?
Your answer should be very brief. 0.64. What is the ratio of the Expenses (in $) in Ghana in 2004 to that in 2009?
Ensure brevity in your answer.  0.23. What is the ratio of the Expenses (in $) of Kenya in 2004 to that in 2009?
Offer a very short reply. 0.76. What is the ratio of the Expenses (in $) of Chile in 2005 to that in 2006?
Provide a succinct answer. 0.87. What is the ratio of the Expenses (in $) of Estonia in 2005 to that in 2006?
Your answer should be compact. 0.87. What is the ratio of the Expenses (in $) of Kenya in 2005 to that in 2006?
Provide a succinct answer. 1.22. What is the ratio of the Expenses (in $) of Chile in 2005 to that in 2007?
Offer a terse response. 0.73. What is the ratio of the Expenses (in $) of Estonia in 2005 to that in 2007?
Your answer should be very brief. 0.77. What is the ratio of the Expenses (in $) of Ghana in 2005 to that in 2007?
Give a very brief answer. 0.65. What is the ratio of the Expenses (in $) of Kenya in 2005 to that in 2007?
Provide a succinct answer. 1.09. What is the ratio of the Expenses (in $) of Chile in 2005 to that in 2008?
Offer a terse response. 0.72. What is the ratio of the Expenses (in $) in Estonia in 2005 to that in 2008?
Offer a terse response. 0.68. What is the ratio of the Expenses (in $) in Ghana in 2005 to that in 2008?
Your answer should be compact. 0.54. What is the ratio of the Expenses (in $) of Kenya in 2005 to that in 2008?
Make the answer very short. 0.67. What is the ratio of the Expenses (in $) in Chile in 2005 to that in 2009?
Your answer should be very brief. 0.59. What is the ratio of the Expenses (in $) in Estonia in 2005 to that in 2009?
Ensure brevity in your answer.  0.7. What is the ratio of the Expenses (in $) in Ghana in 2005 to that in 2009?
Your answer should be very brief. 0.37. What is the ratio of the Expenses (in $) in Kenya in 2005 to that in 2009?
Your answer should be very brief. 0.6. What is the ratio of the Expenses (in $) in Chile in 2006 to that in 2007?
Offer a terse response. 0.84. What is the ratio of the Expenses (in $) of Estonia in 2006 to that in 2007?
Provide a succinct answer. 0.88. What is the ratio of the Expenses (in $) in Ghana in 2006 to that in 2007?
Provide a succinct answer. 0.74. What is the ratio of the Expenses (in $) of Kenya in 2006 to that in 2007?
Your answer should be very brief. 0.89. What is the ratio of the Expenses (in $) in Chile in 2006 to that in 2008?
Your answer should be compact. 0.82. What is the ratio of the Expenses (in $) of Estonia in 2006 to that in 2008?
Ensure brevity in your answer.  0.77. What is the ratio of the Expenses (in $) in Ghana in 2006 to that in 2008?
Ensure brevity in your answer.  0.61. What is the ratio of the Expenses (in $) in Kenya in 2006 to that in 2008?
Your response must be concise. 0.55. What is the ratio of the Expenses (in $) of Chile in 2006 to that in 2009?
Offer a terse response. 0.68. What is the ratio of the Expenses (in $) in Estonia in 2006 to that in 2009?
Provide a succinct answer. 0.8. What is the ratio of the Expenses (in $) in Ghana in 2006 to that in 2009?
Your answer should be very brief. 0.42. What is the ratio of the Expenses (in $) in Kenya in 2006 to that in 2009?
Provide a succinct answer. 0.49. What is the ratio of the Expenses (in $) in Chile in 2007 to that in 2008?
Offer a very short reply. 0.98. What is the ratio of the Expenses (in $) of Estonia in 2007 to that in 2008?
Provide a short and direct response. 0.88. What is the ratio of the Expenses (in $) of Ghana in 2007 to that in 2008?
Offer a terse response. 0.83. What is the ratio of the Expenses (in $) in Kenya in 2007 to that in 2008?
Ensure brevity in your answer.  0.62. What is the ratio of the Expenses (in $) in Chile in 2007 to that in 2009?
Your response must be concise. 0.81. What is the ratio of the Expenses (in $) in Estonia in 2007 to that in 2009?
Your answer should be compact. 0.91. What is the ratio of the Expenses (in $) of Ghana in 2007 to that in 2009?
Keep it short and to the point. 0.57. What is the ratio of the Expenses (in $) in Kenya in 2007 to that in 2009?
Make the answer very short. 0.55. What is the ratio of the Expenses (in $) of Chile in 2008 to that in 2009?
Your answer should be very brief. 0.83. What is the ratio of the Expenses (in $) in Estonia in 2008 to that in 2009?
Provide a succinct answer. 1.04. What is the ratio of the Expenses (in $) of Ghana in 2008 to that in 2009?
Make the answer very short. 0.68. What is the ratio of the Expenses (in $) in Kenya in 2008 to that in 2009?
Offer a very short reply. 0.89. What is the difference between the highest and the second highest Expenses (in $) in Chile?
Give a very brief answer. 3.58e+11. What is the difference between the highest and the second highest Expenses (in $) of Estonia?
Give a very brief answer. 2.36e+07. What is the difference between the highest and the second highest Expenses (in $) of Ghana?
Ensure brevity in your answer.  3.44e+08. What is the difference between the highest and the second highest Expenses (in $) in Kenya?
Ensure brevity in your answer.  1.06e+1. What is the difference between the highest and the lowest Expenses (in $) of Chile?
Ensure brevity in your answer.  1.23e+12. What is the difference between the highest and the lowest Expenses (in $) in Estonia?
Keep it short and to the point. 2.56e+08. What is the difference between the highest and the lowest Expenses (in $) of Ghana?
Your answer should be compact. 8.81e+08. What is the difference between the highest and the lowest Expenses (in $) of Kenya?
Provide a succinct answer. 5.06e+1. 